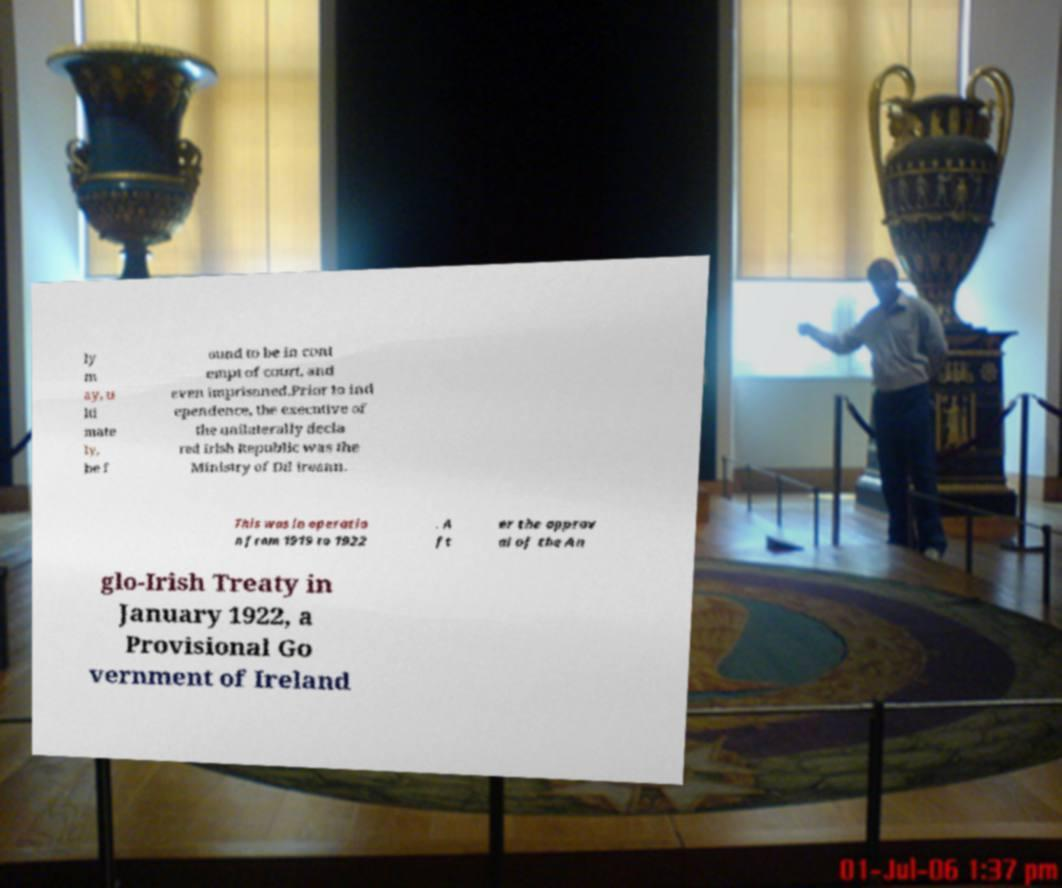There's text embedded in this image that I need extracted. Can you transcribe it verbatim? ly m ay, u lti mate ly, be f ound to be in cont empt of court, and even imprisoned.Prior to ind ependence, the executive of the unilaterally decla red Irish Republic was the Ministry of Dil ireann. This was in operatio n from 1919 to 1922 . A ft er the approv al of the An glo-Irish Treaty in January 1922, a Provisional Go vernment of Ireland 